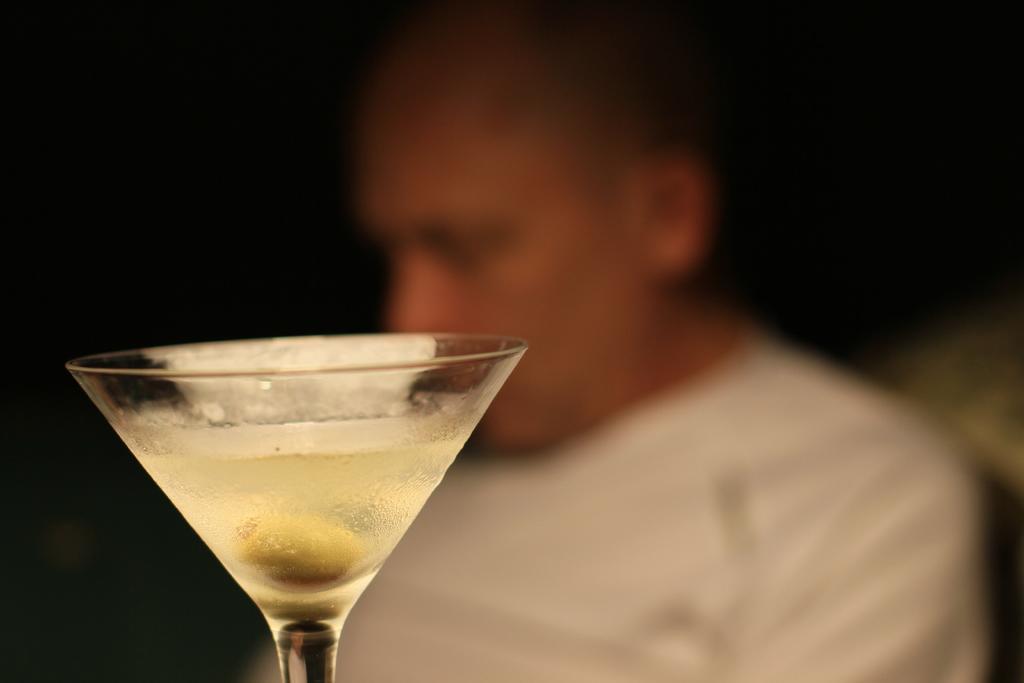Could you give a brief overview of what you see in this image? In this image there is a glass. There is drink in the glass. At the bottom of the glass there is an object. Behind the glass there is a person. The background is blurry. 